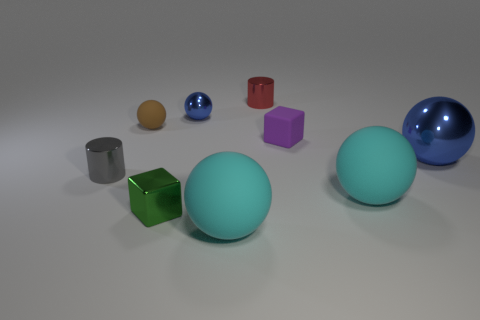Can you describe the textures visible in the image? Certainly! The balls and several other shapes have smooth surfaces, reflecting light and showcasing shiny textures. Specifically, the large blue and sea-green balls, along with a smaller blue one and a silver cylinder, have high gloss finishes. The remaining shapes, which include cubes and a smaller ball, have matte surfaces that absorb more light and appear less reflective. 